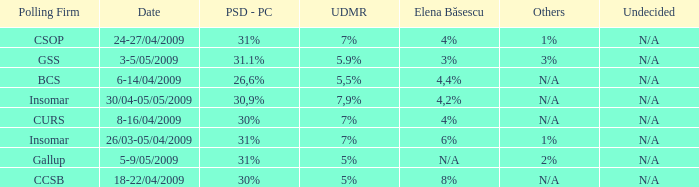What was the UDMR for 18-22/04/2009? 5%. 